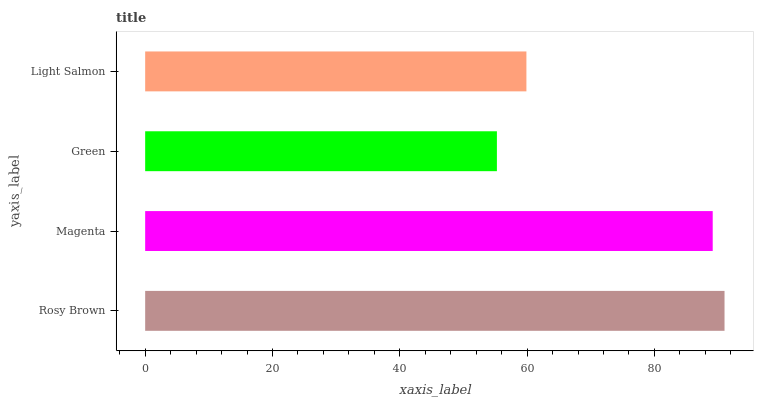Is Green the minimum?
Answer yes or no. Yes. Is Rosy Brown the maximum?
Answer yes or no. Yes. Is Magenta the minimum?
Answer yes or no. No. Is Magenta the maximum?
Answer yes or no. No. Is Rosy Brown greater than Magenta?
Answer yes or no. Yes. Is Magenta less than Rosy Brown?
Answer yes or no. Yes. Is Magenta greater than Rosy Brown?
Answer yes or no. No. Is Rosy Brown less than Magenta?
Answer yes or no. No. Is Magenta the high median?
Answer yes or no. Yes. Is Light Salmon the low median?
Answer yes or no. Yes. Is Light Salmon the high median?
Answer yes or no. No. Is Rosy Brown the low median?
Answer yes or no. No. 